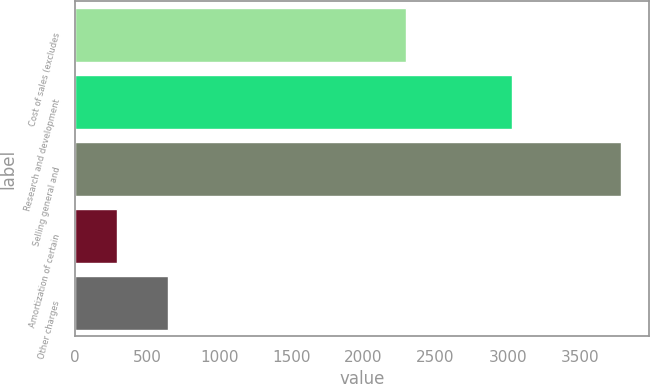Convert chart. <chart><loc_0><loc_0><loc_500><loc_500><bar_chart><fcel>Cost of sales (excludes<fcel>Research and development<fcel>Selling general and<fcel>Amortization of certain<fcel>Other charges<nl><fcel>2296<fcel>3030<fcel>3789<fcel>294<fcel>643.5<nl></chart> 